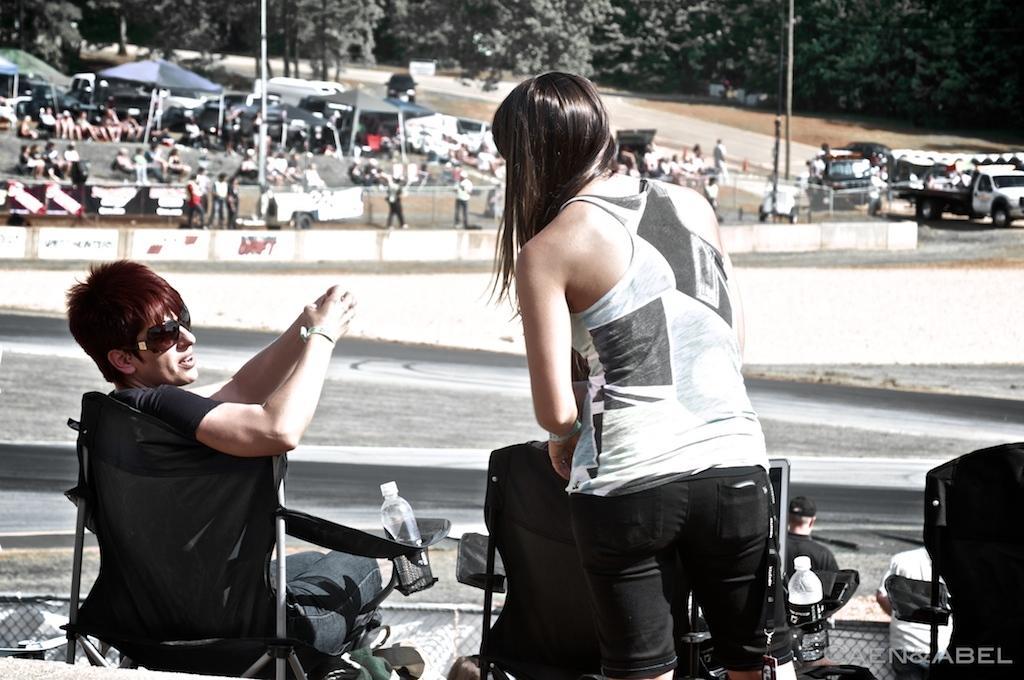Could you give a brief overview of what you see in this image? In this image I can see a man and a woman and this looking like a garden area/open place and here is some people sitting over here and some people are walking over here I can see trees over here and some cars. 